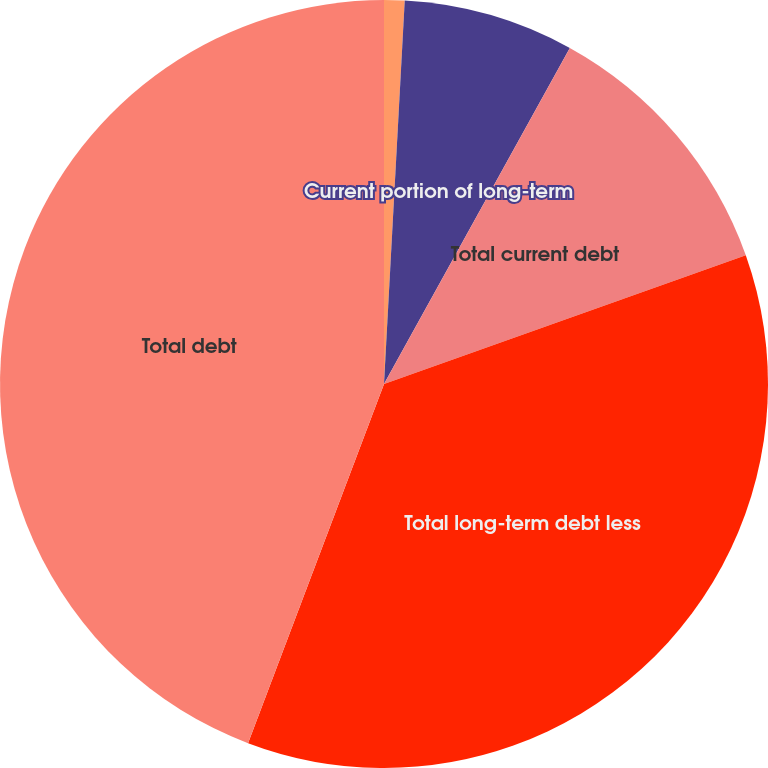Convert chart to OTSL. <chart><loc_0><loc_0><loc_500><loc_500><pie_chart><fcel>Short-term borrowings<fcel>Current portion of long-term<fcel>Total current debt<fcel>Total long-term debt less<fcel>Total debt<nl><fcel>0.86%<fcel>7.18%<fcel>11.52%<fcel>36.2%<fcel>44.24%<nl></chart> 